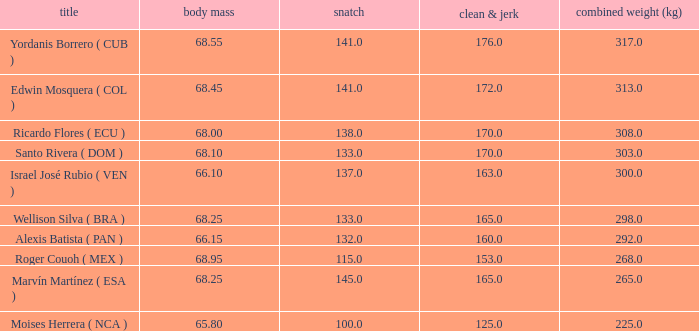Which Total (kg) has a Clean & Jerk smaller than 153, and a Snatch smaller than 100? None. Could you parse the entire table? {'header': ['title', 'body mass', 'snatch', 'clean & jerk', 'combined weight (kg)'], 'rows': [['Yordanis Borrero ( CUB )', '68.55', '141.0', '176.0', '317.0'], ['Edwin Mosquera ( COL )', '68.45', '141.0', '172.0', '313.0'], ['Ricardo Flores ( ECU )', '68.00', '138.0', '170.0', '308.0'], ['Santo Rivera ( DOM )', '68.10', '133.0', '170.0', '303.0'], ['Israel José Rubio ( VEN )', '66.10', '137.0', '163.0', '300.0'], ['Wellison Silva ( BRA )', '68.25', '133.0', '165.0', '298.0'], ['Alexis Batista ( PAN )', '66.15', '132.0', '160.0', '292.0'], ['Roger Couoh ( MEX )', '68.95', '115.0', '153.0', '268.0'], ['Marvín Martínez ( ESA )', '68.25', '145.0', '165.0', '265.0'], ['Moises Herrera ( NCA )', '65.80', '100.0', '125.0', '225.0']]} 